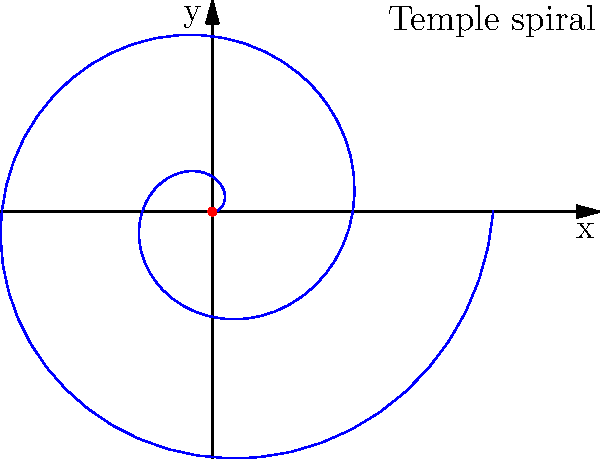A Mayan temple's spiral staircase can be modeled using the polar equation $r = 0.2\theta$, where $r$ is in meters and $\theta$ is in radians. If a tourist climbs the staircase for two full revolutions, what is the straight-line distance (in meters) from their starting point to their ending point? Let's approach this step-by-step:

1) The polar equation is given as $r = 0.2\theta$.

2) Two full revolutions means $\theta = 4\pi$ radians.

3) At the end point, we can calculate $r$:
   $r = 0.2 * 4\pi = 0.8\pi$ meters

4) Now, we have the polar coordinates of the end point: $(0.8\pi, 4\pi)$.

5) To find the straight-line distance, we need to convert this to Cartesian coordinates:
   $x = r \cos(\theta) = 0.8\pi \cos(4\pi) = 0.8\pi$
   $y = r \sin(\theta) = 0.8\pi \sin(4\pi) = 0$

6) The straight-line distance is the distance from (0,0) to $(0.8\pi, 0)$.

7) We can calculate this using the distance formula:
   $d = \sqrt{(x_2-x_1)^2 + (y_2-y_1)^2} = \sqrt{(0.8\pi-0)^2 + (0-0)^2} = 0.8\pi$

Therefore, the straight-line distance is $0.8\pi$ meters.
Answer: $0.8\pi$ meters 